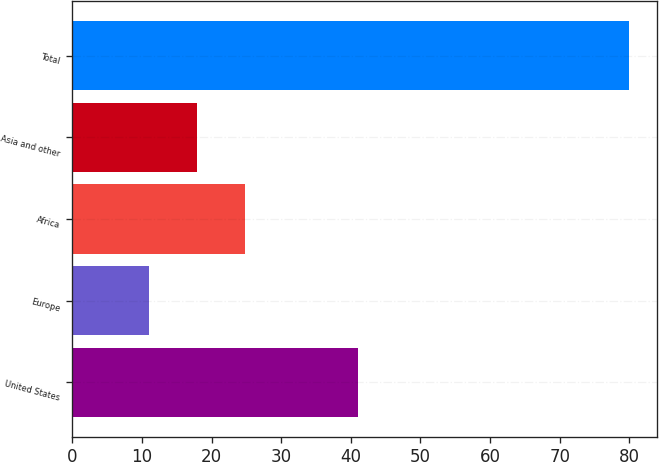<chart> <loc_0><loc_0><loc_500><loc_500><bar_chart><fcel>United States<fcel>Europe<fcel>Africa<fcel>Asia and other<fcel>Total<nl><fcel>41<fcel>11<fcel>24.8<fcel>17.9<fcel>80<nl></chart> 